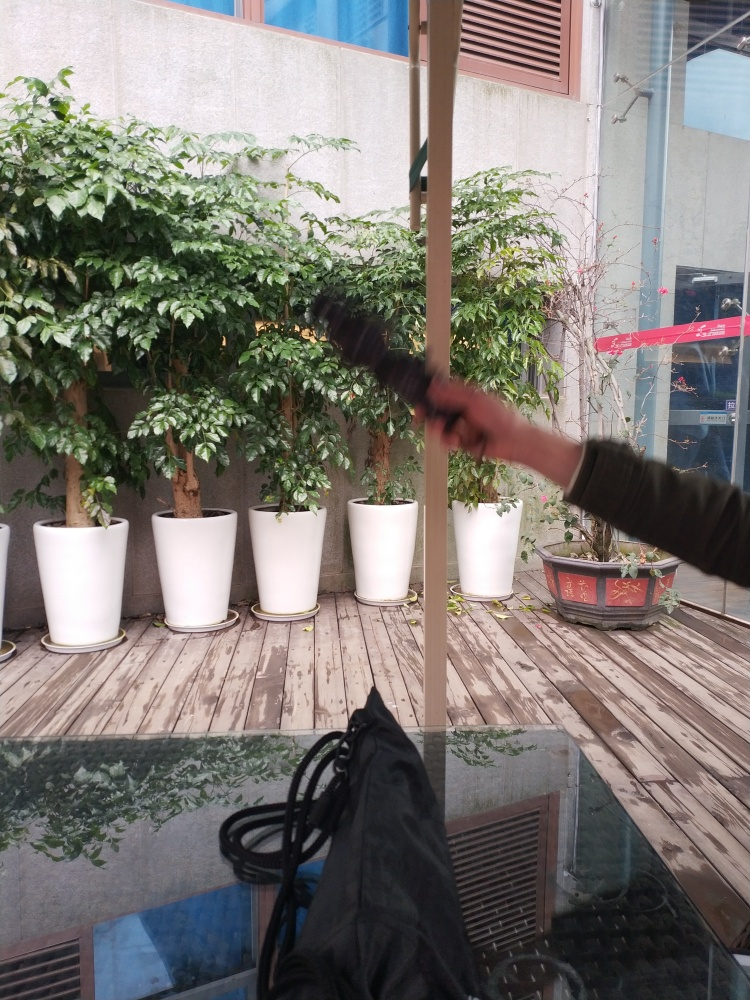Can you describe the setting of this image? This image appears to be taken in an indoor location, possibly a lobby or an atrium, where large potted plants are lined up against a wall with a window. There's a wooden flooring under the pots, and the reflection in the glass suggests a ceiling with hanging lights. There appears to be a balcony or a second level above. The inclusion of a blurred moving object in the foreground adds a dynamic element to the otherwise still setting. 